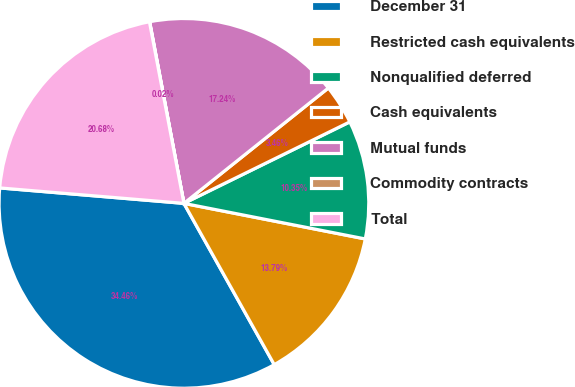<chart> <loc_0><loc_0><loc_500><loc_500><pie_chart><fcel>December 31<fcel>Restricted cash equivalents<fcel>Nonqualified deferred<fcel>Cash equivalents<fcel>Mutual funds<fcel>Commodity contracts<fcel>Total<nl><fcel>34.46%<fcel>13.79%<fcel>10.35%<fcel>3.46%<fcel>17.24%<fcel>0.02%<fcel>20.68%<nl></chart> 